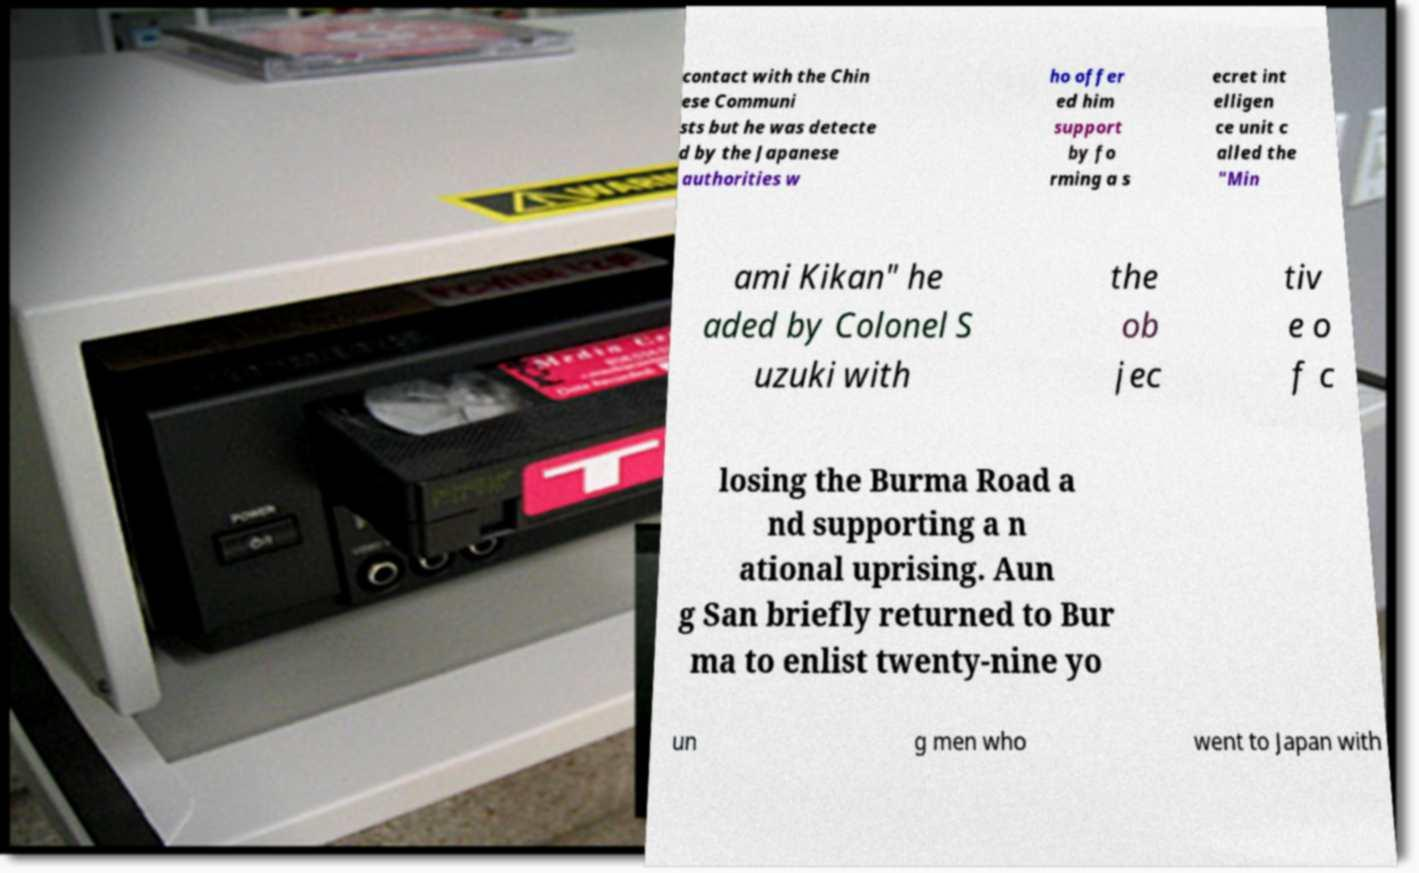Please read and relay the text visible in this image. What does it say? contact with the Chin ese Communi sts but he was detecte d by the Japanese authorities w ho offer ed him support by fo rming a s ecret int elligen ce unit c alled the "Min ami Kikan" he aded by Colonel S uzuki with the ob jec tiv e o f c losing the Burma Road a nd supporting a n ational uprising. Aun g San briefly returned to Bur ma to enlist twenty-nine yo un g men who went to Japan with 